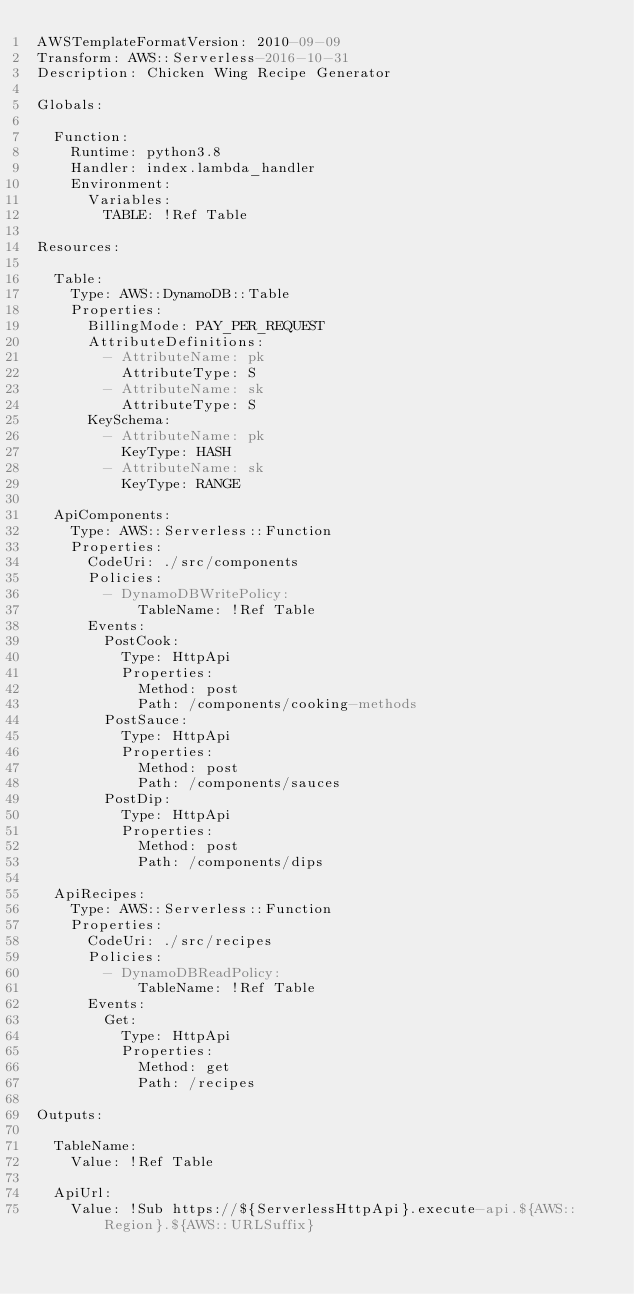<code> <loc_0><loc_0><loc_500><loc_500><_YAML_>AWSTemplateFormatVersion: 2010-09-09
Transform: AWS::Serverless-2016-10-31
Description: Chicken Wing Recipe Generator

Globals:

  Function:
    Runtime: python3.8
    Handler: index.lambda_handler
    Environment:
      Variables:
        TABLE: !Ref Table

Resources:

  Table:
    Type: AWS::DynamoDB::Table
    Properties:
      BillingMode: PAY_PER_REQUEST
      AttributeDefinitions:
        - AttributeName: pk
          AttributeType: S
        - AttributeName: sk
          AttributeType: S
      KeySchema:
        - AttributeName: pk
          KeyType: HASH
        - AttributeName: sk
          KeyType: RANGE

  ApiComponents:
    Type: AWS::Serverless::Function
    Properties:
      CodeUri: ./src/components
      Policies:
        - DynamoDBWritePolicy:
            TableName: !Ref Table
      Events:
        PostCook:
          Type: HttpApi
          Properties:
            Method: post
            Path: /components/cooking-methods
        PostSauce:
          Type: HttpApi
          Properties:
            Method: post
            Path: /components/sauces
        PostDip:
          Type: HttpApi
          Properties:
            Method: post
            Path: /components/dips

  ApiRecipes:
    Type: AWS::Serverless::Function
    Properties:
      CodeUri: ./src/recipes
      Policies:
        - DynamoDBReadPolicy:
            TableName: !Ref Table
      Events:
        Get:
          Type: HttpApi
          Properties:
            Method: get
            Path: /recipes

Outputs:

  TableName:
    Value: !Ref Table

  ApiUrl:
    Value: !Sub https://${ServerlessHttpApi}.execute-api.${AWS::Region}.${AWS::URLSuffix}
</code> 